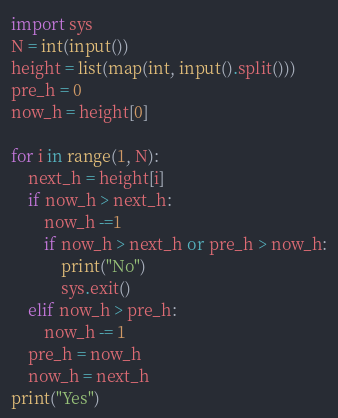Convert code to text. <code><loc_0><loc_0><loc_500><loc_500><_Python_>import sys
N = int(input())
height = list(map(int, input().split()))
pre_h = 0
now_h = height[0]

for i in range(1, N):
    next_h = height[i]
    if now_h > next_h:
        now_h -=1
        if now_h > next_h or pre_h > now_h:
            print("No")
            sys.exit()
    elif now_h > pre_h:
        now_h -= 1
    pre_h = now_h
    now_h = next_h
print("Yes")</code> 